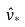<formula> <loc_0><loc_0><loc_500><loc_500>\hat { v } _ { * }</formula> 